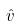<formula> <loc_0><loc_0><loc_500><loc_500>\hat { v }</formula> 